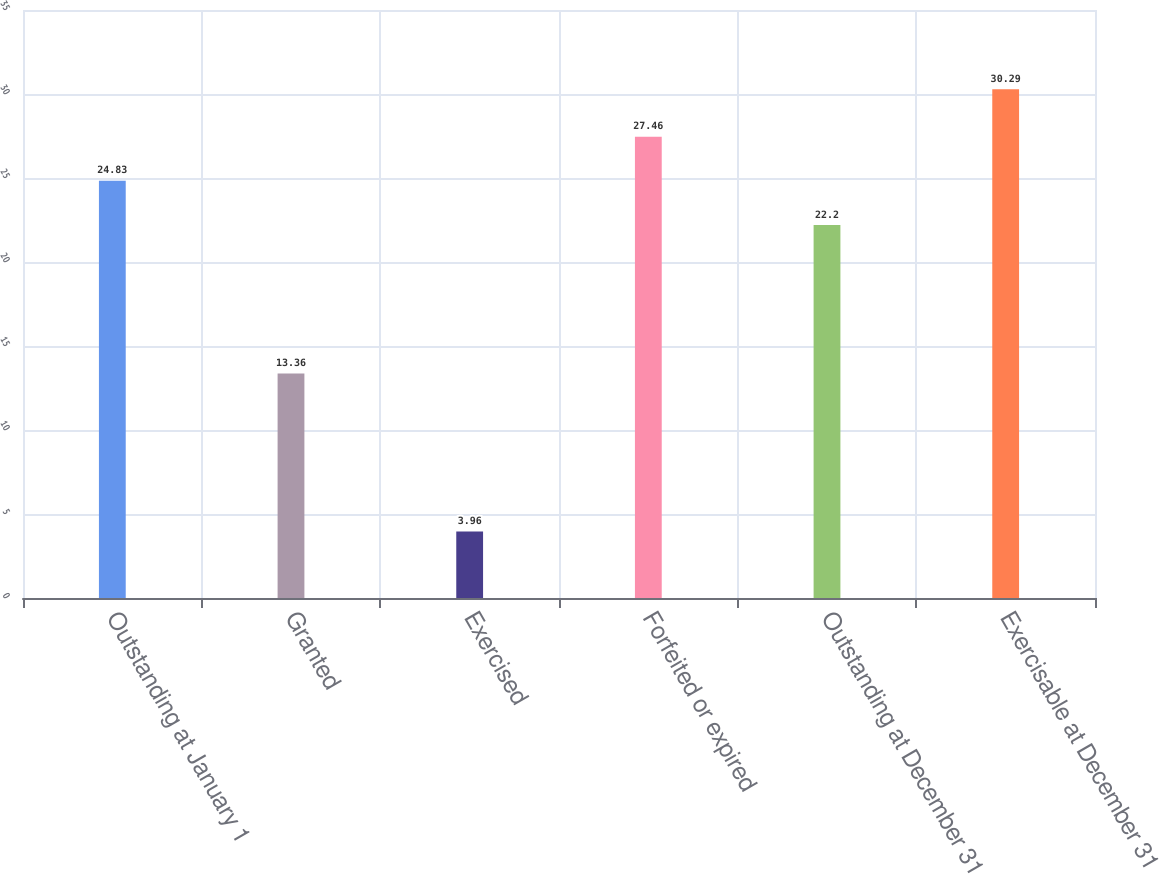Convert chart to OTSL. <chart><loc_0><loc_0><loc_500><loc_500><bar_chart><fcel>Outstanding at January 1<fcel>Granted<fcel>Exercised<fcel>Forfeited or expired<fcel>Outstanding at December 31<fcel>Exercisable at December 31<nl><fcel>24.83<fcel>13.36<fcel>3.96<fcel>27.46<fcel>22.2<fcel>30.29<nl></chart> 